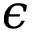Convert formula to latex. <formula><loc_0><loc_0><loc_500><loc_500>\epsilon</formula> 